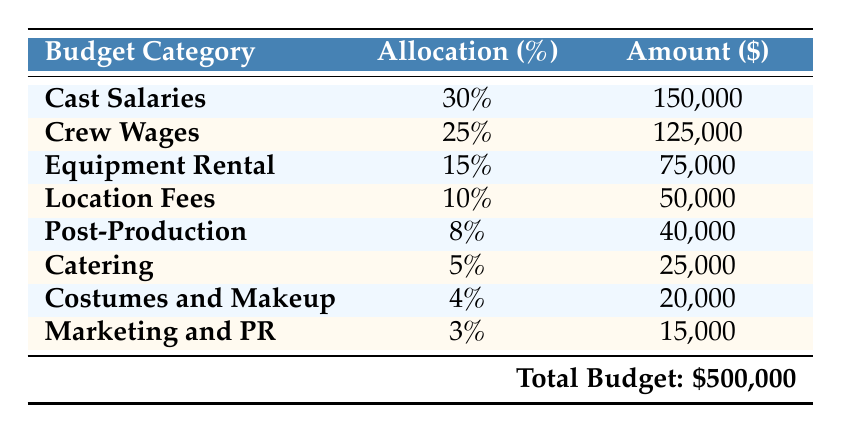What is the total budget for the film production? The table explicitly states the total budget at the bottom, which is \$500,000.
Answer: 500,000 What percentage of the total budget is allocated to cast salaries? The table shows that cast salaries are allocated 30% of the total budget.
Answer: 30% Which category has the lowest allocation percentage? By examining the rows in the table, the marketing and PR category has the lowest allocation at 3%.
Answer: Marketing and PR What is the total allocation percentage for crew wages and post-production combined? To find the total, add the percentages for crew wages (25%) and post-production (8%): 25% + 8% = 33%.
Answer: 33% Is the amount allocated for equipment rental greater than that for catering? Equipment rental has \$75,000 allocated, while catering has \$25,000. Therefore, \$75,000 is greater than \$25,000, making the statement true.
Answer: Yes If the film production budget were \$700,000, what would be the new allocation amount for costumes and makeup? Costumes and makeup receive 4% of the total budget. Calculate 4% of \$700,000: 0.04 * 700,000 = \$28,000.
Answer: 28,000 What is the difference in allocation amounts between crew wages and location fees? Crew wages receive \$125,000 while location fees receive \$50,000. The difference is \$125,000 - \$50,000 = \$75,000.
Answer: 75,000 If the total budget were reduced by \$100,000, what would be the new amount allocated for post-production? The original allocation for post-production is \$40,000. The percentage (8%) would remain the same. Calculate 8% of the new budget: (500,000 - 100,000) = \$400,000; 0.08 * 400,000 = \$32,000.
Answer: 32,000 What percentage of the total budget is allocated to catering compared to cast salaries? Catering is allocated 5%, and cast salaries are allocated 30%. The ratio of catering to cast salaries is 5% / 30% = 1/6, or approximately 16.67%.
Answer: 16.67% 